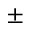Convert formula to latex. <formula><loc_0><loc_0><loc_500><loc_500>\pm</formula> 